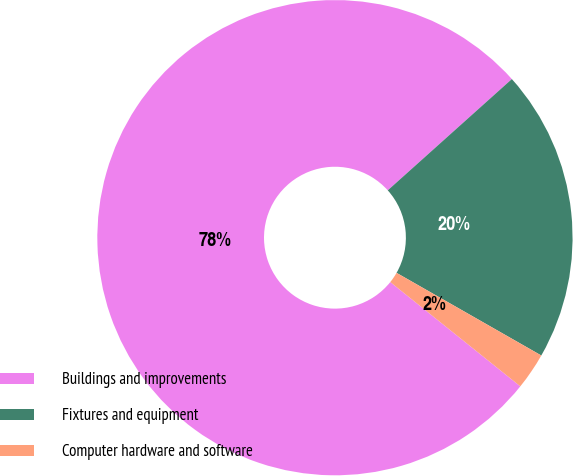<chart> <loc_0><loc_0><loc_500><loc_500><pie_chart><fcel>Buildings and improvements<fcel>Fixtures and equipment<fcel>Computer hardware and software<nl><fcel>77.61%<fcel>19.89%<fcel>2.5%<nl></chart> 